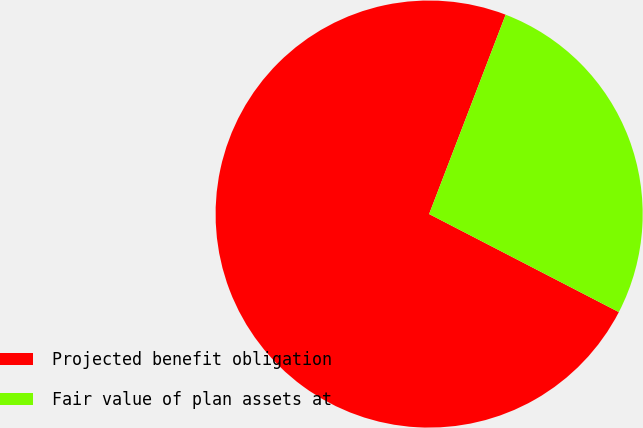<chart> <loc_0><loc_0><loc_500><loc_500><pie_chart><fcel>Projected benefit obligation<fcel>Fair value of plan assets at<nl><fcel>73.24%<fcel>26.76%<nl></chart> 